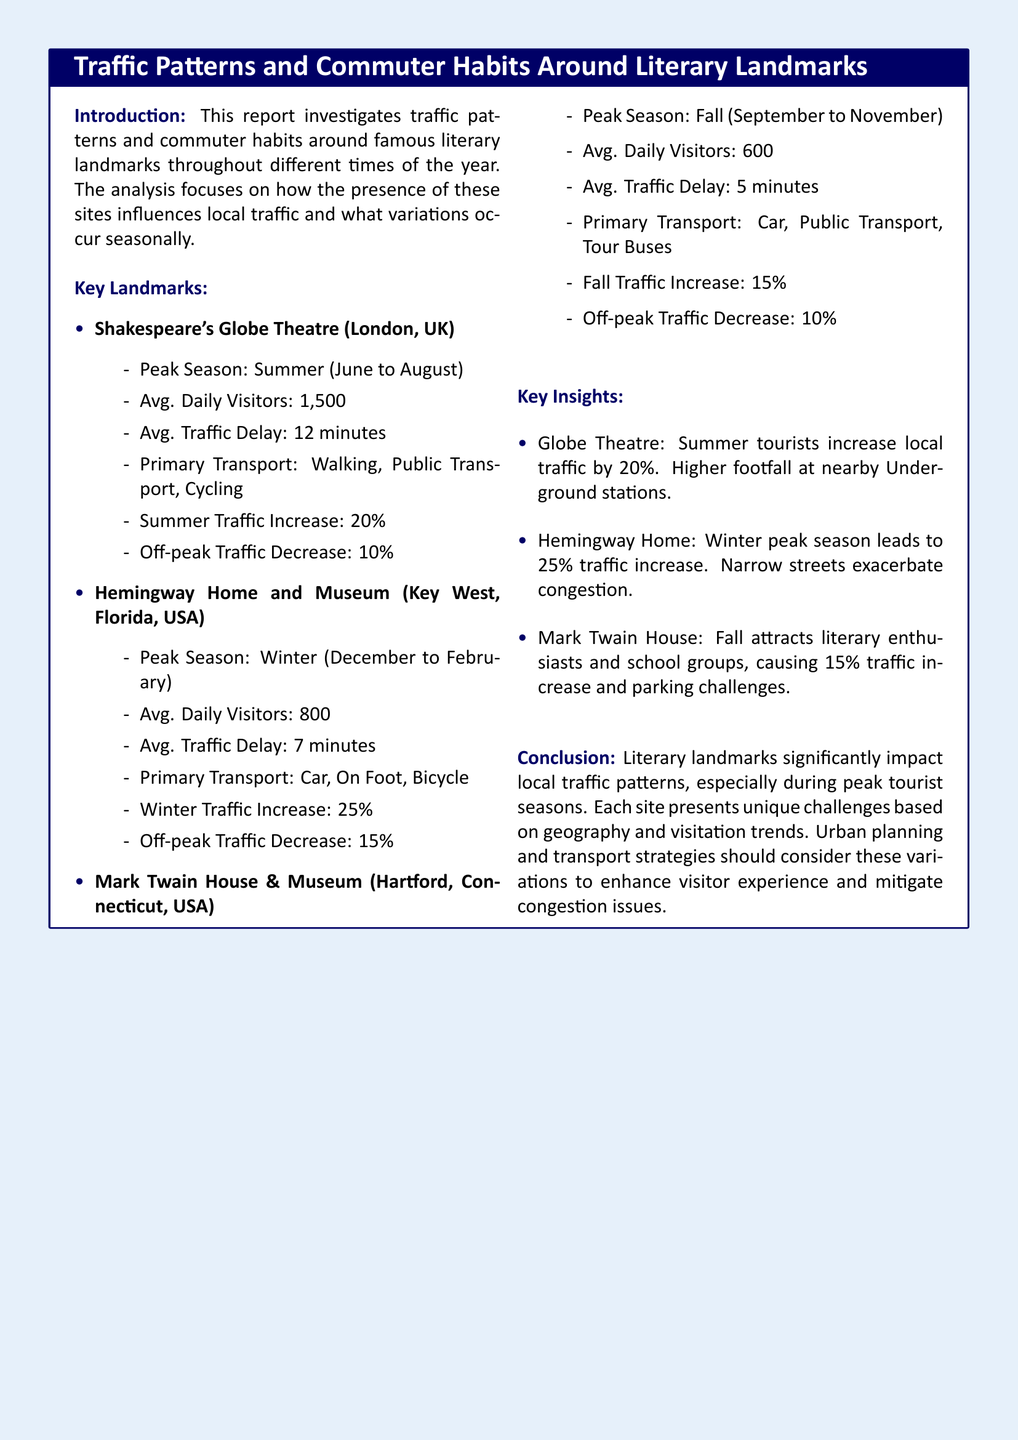What is the peak season for Shakespeare's Globe Theatre? The peak season for Shakespeare's Globe Theatre is during the summer months from June to August.
Answer: Summer What is the average daily visitors for Hemingway Home and Museum? The average daily visitors for Hemingway Home and Museum is 800.
Answer: 800 What is the average traffic delay at Mark Twain House & Museum? The average traffic delay at Mark Twain House & Museum is 5 minutes.
Answer: 5 minutes By what percentage does traffic increase during the winter peak season at Hemingway Home? Traffic increases by 25% during the winter peak season at Hemingway Home.
Answer: 25% Which literary landmark has the highest average daily visitors? The literary landmark with the highest average daily visitors is Shakespeare's Globe Theatre, with 1,500 visitors.
Answer: Shakespeare's Globe Theatre What are the primary transport modes for visitors to the Mark Twain House? The primary transport modes for visitors to the Mark Twain House are car, public transport, and tour buses.
Answer: Car, public transport, tour buses What unique challenge does the Hemingway Home face due to its street conditions during peak season? The unique challenge faced by the Hemingway Home is that narrow streets exacerbate congestion during peak season.
Answer: Congestion During which season do school groups generally visit the Mark Twain House? School groups generally visit the Mark Twain House during the fall season.
Answer: Fall How much does traffic delay increase in summer at Shakespeare's Globe Theatre? Traffic delay increases by an average of 12 minutes in summer at Shakespeare's Globe Theatre.
Answer: 12 minutes 